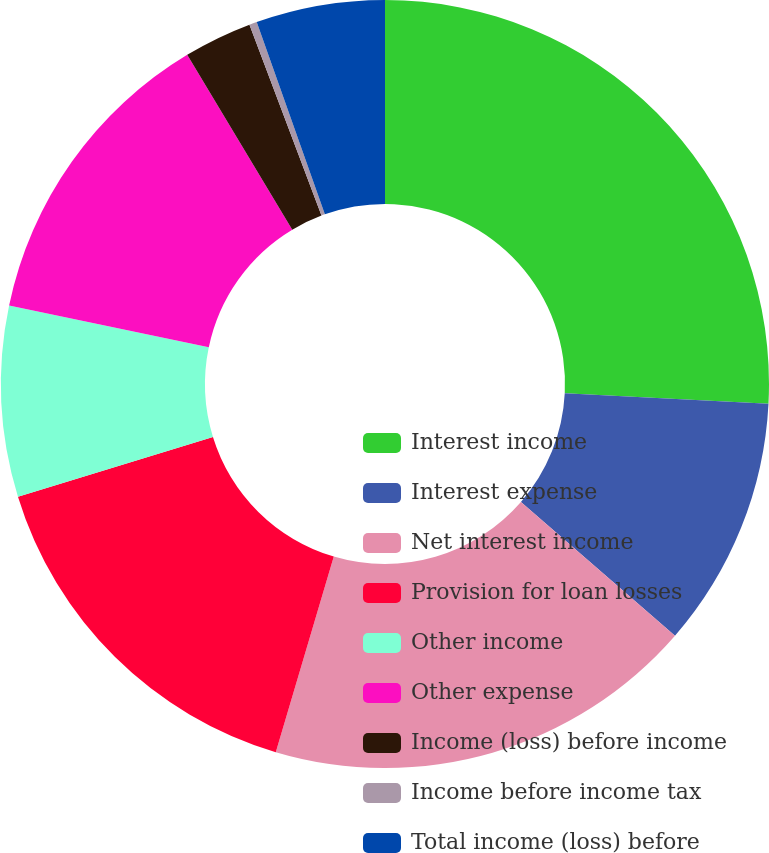<chart> <loc_0><loc_0><loc_500><loc_500><pie_chart><fcel>Interest income<fcel>Interest expense<fcel>Net interest income<fcel>Provision for loan losses<fcel>Other income<fcel>Other expense<fcel>Income (loss) before income<fcel>Income before income tax<fcel>Total income (loss) before<nl><fcel>25.81%<fcel>10.56%<fcel>18.21%<fcel>15.66%<fcel>8.02%<fcel>13.11%<fcel>2.87%<fcel>0.32%<fcel>5.42%<nl></chart> 